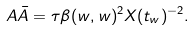Convert formula to latex. <formula><loc_0><loc_0><loc_500><loc_500>A \bar { A } = \tau \beta ( w , w ) ^ { 2 } X ( t _ { w } ) ^ { - 2 } .</formula> 